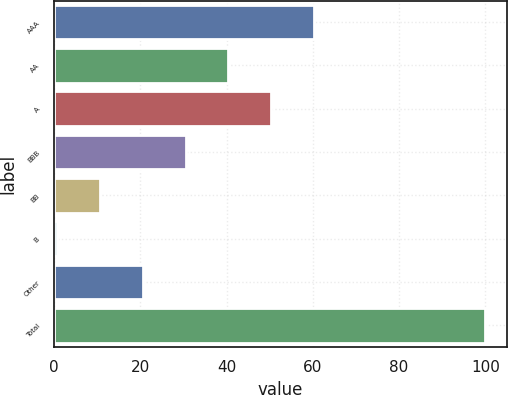Convert chart to OTSL. <chart><loc_0><loc_0><loc_500><loc_500><bar_chart><fcel>AAA<fcel>AA<fcel>A<fcel>BBB<fcel>BB<fcel>B<fcel>Other<fcel>Total<nl><fcel>60.28<fcel>40.42<fcel>50.35<fcel>30.49<fcel>10.63<fcel>0.7<fcel>20.56<fcel>100<nl></chart> 